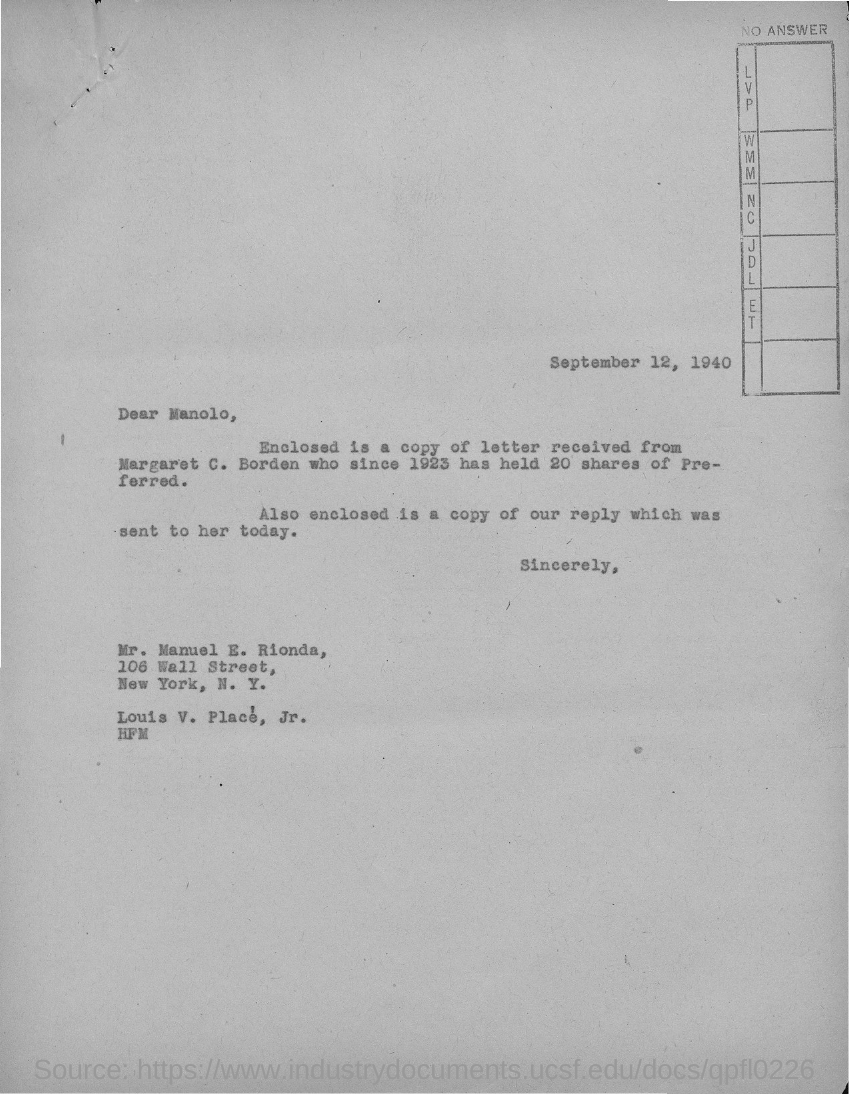Give some essential details in this illustration. The addressee of this letter is Mr. Manuel E. Rionda. The date mentioned in this letter is September 12, 1940. 